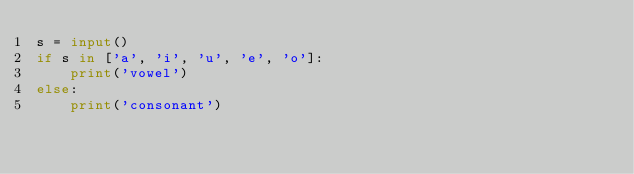Convert code to text. <code><loc_0><loc_0><loc_500><loc_500><_Python_>s = input()
if s in ['a', 'i', 'u', 'e', 'o']:
    print('vowel')
else:
    print('consonant')</code> 